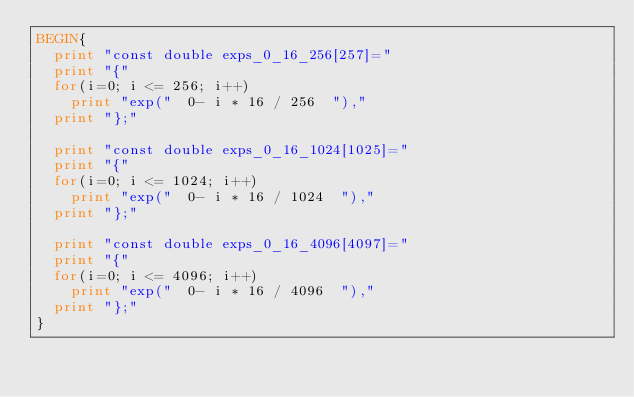<code> <loc_0><loc_0><loc_500><loc_500><_Awk_>BEGIN{
	print "const double exps_0_16_256[257]="
	print "{"
	for(i=0; i <= 256; i++)
		print "exp("  0- i * 16 / 256  "),"
	print "};"

	print "const double exps_0_16_1024[1025]="
	print "{"
	for(i=0; i <= 1024; i++)
		print "exp("  0- i * 16 / 1024  "),"
	print "};"

	print "const double exps_0_16_4096[4097]="
	print "{"
	for(i=0; i <= 4096; i++)
		print "exp("  0- i * 16 / 4096  "),"
	print "};"
}
</code> 